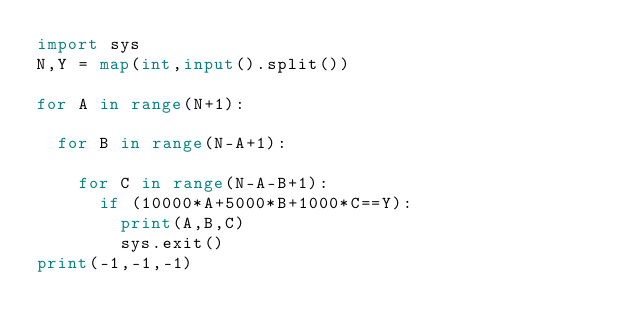Convert code to text. <code><loc_0><loc_0><loc_500><loc_500><_Python_>import sys
N,Y = map(int,input().split())

for A in range(N+1):
  
  for B in range(N-A+1):
    
    for C in range(N-A-B+1):
      if (10000*A+5000*B+1000*C==Y):
        print(A,B,C)        
        sys.exit()
print(-1,-1,-1)</code> 